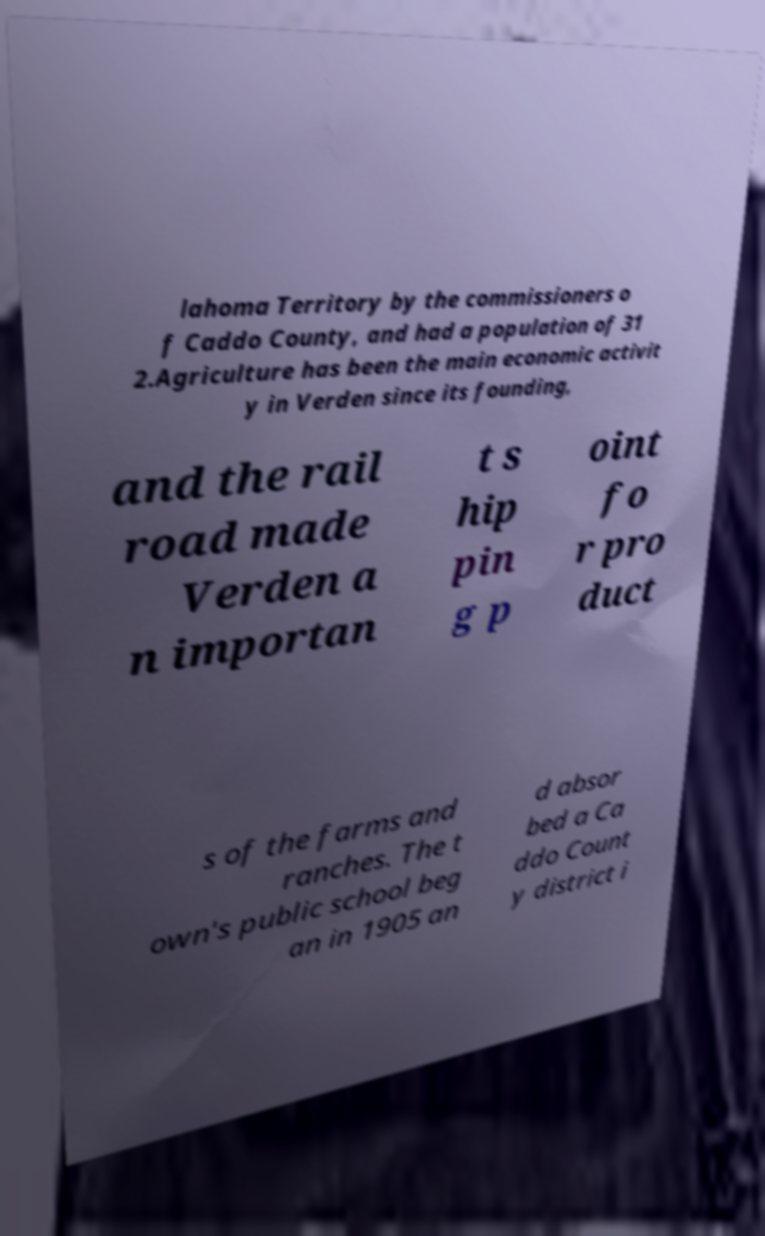There's text embedded in this image that I need extracted. Can you transcribe it verbatim? lahoma Territory by the commissioners o f Caddo County, and had a population of 31 2.Agriculture has been the main economic activit y in Verden since its founding, and the rail road made Verden a n importan t s hip pin g p oint fo r pro duct s of the farms and ranches. The t own's public school beg an in 1905 an d absor bed a Ca ddo Count y district i 